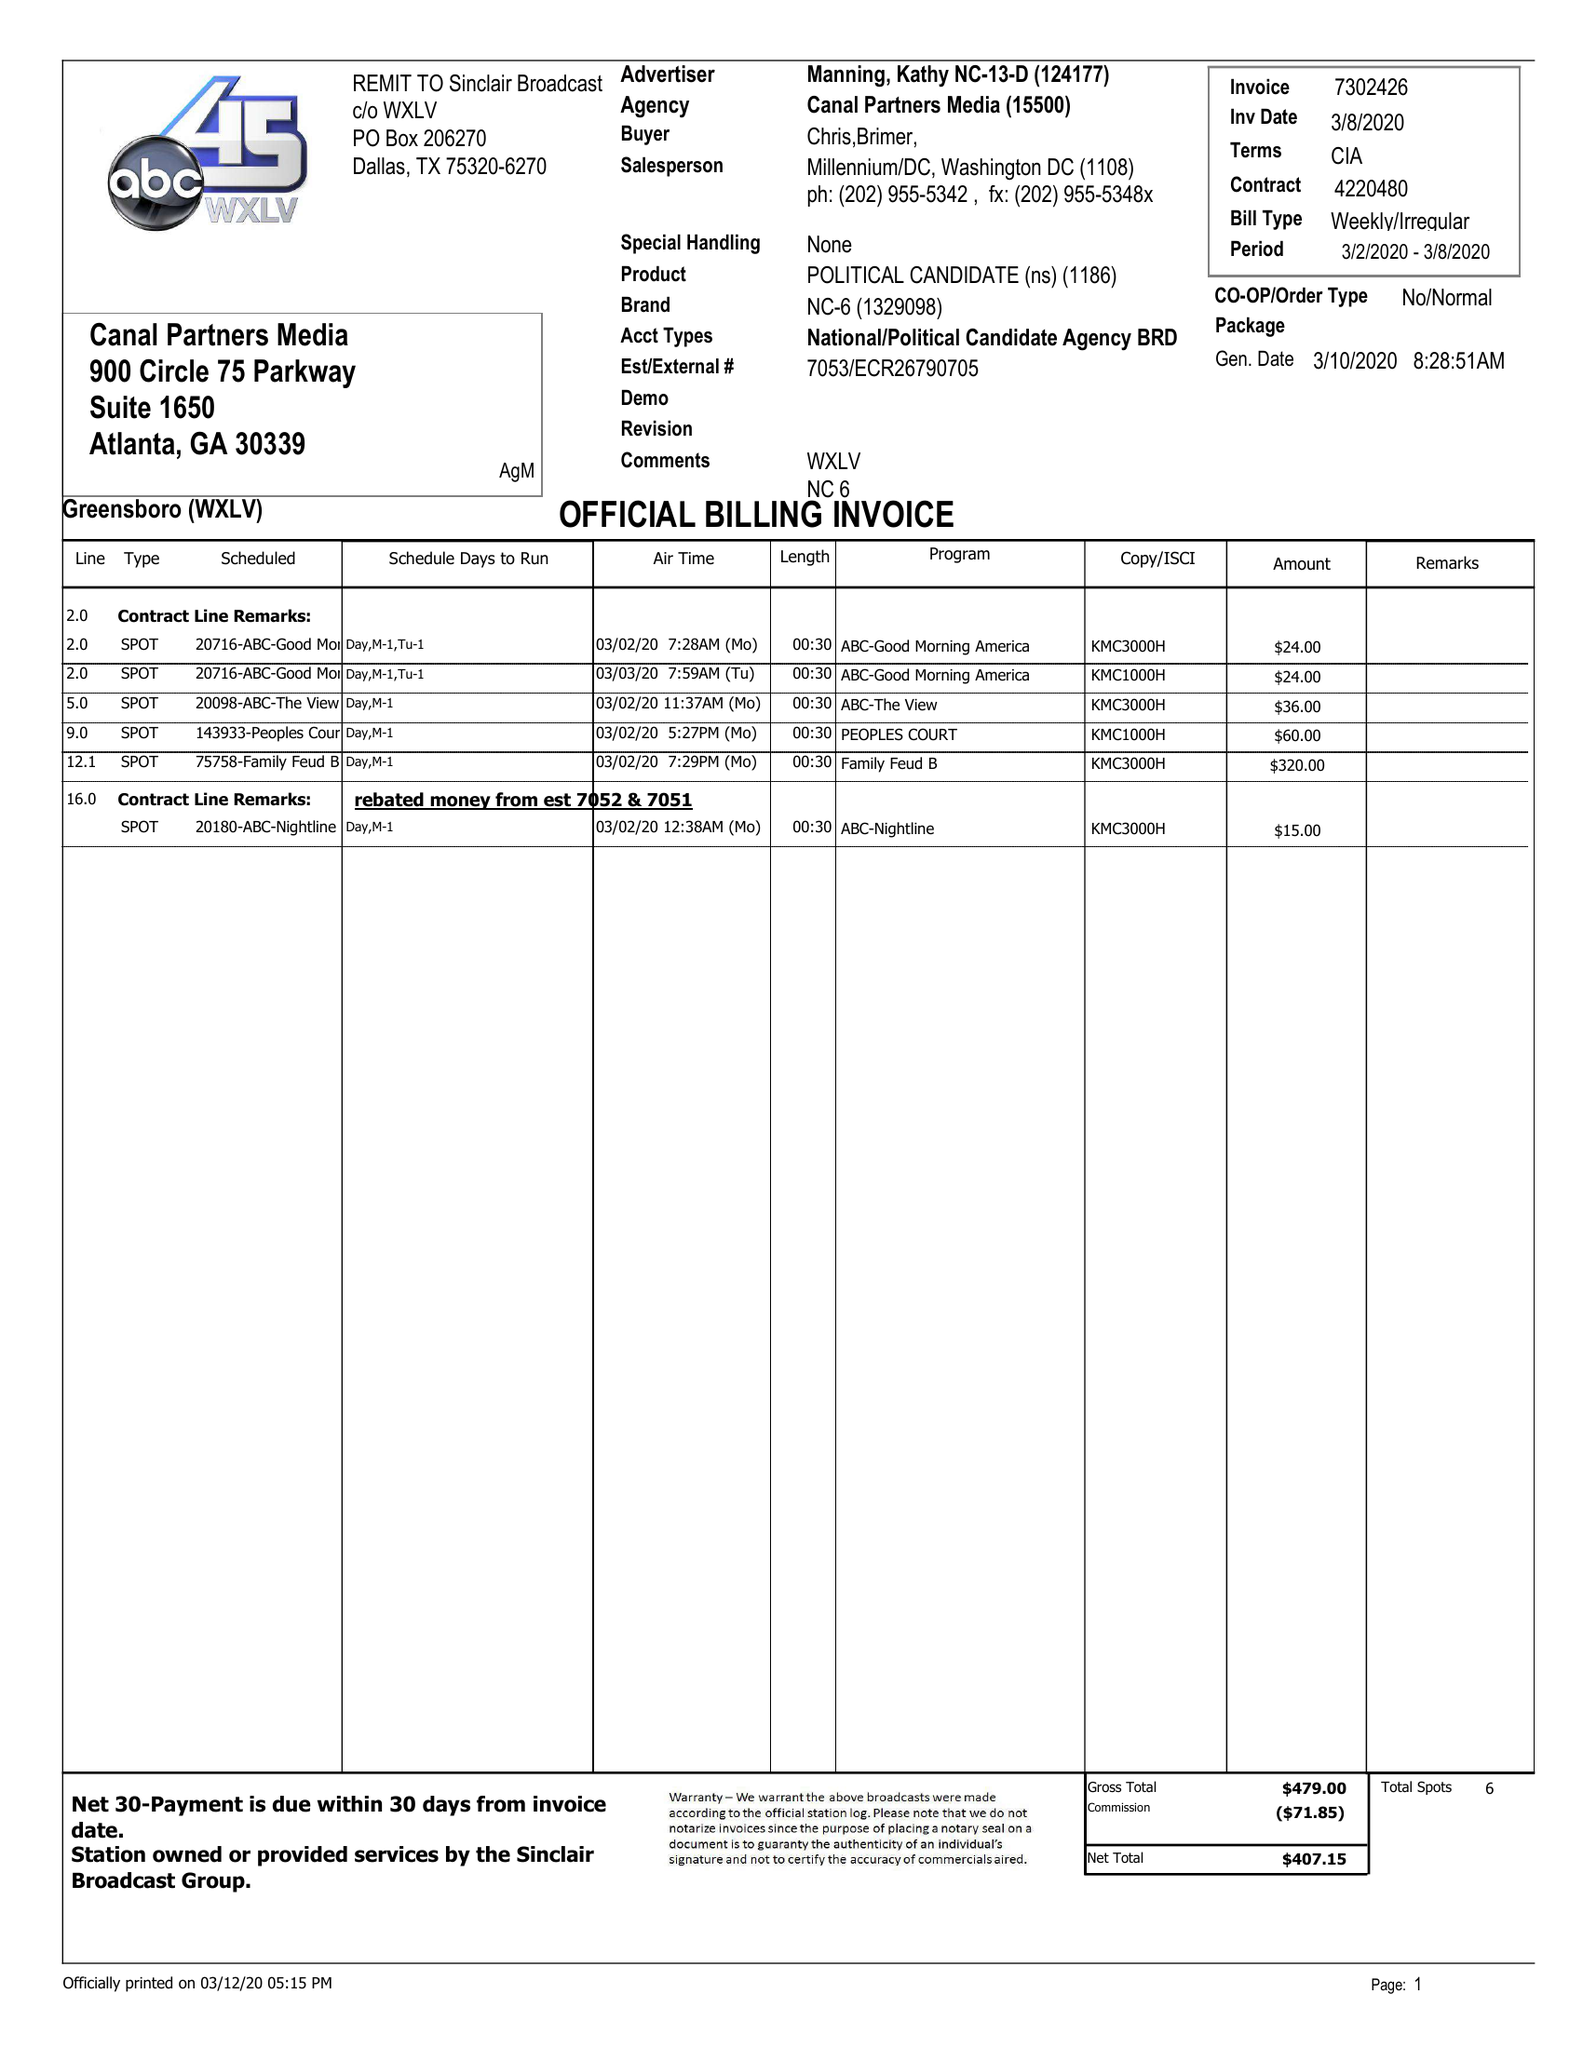What is the value for the flight_from?
Answer the question using a single word or phrase. 03/02/20 